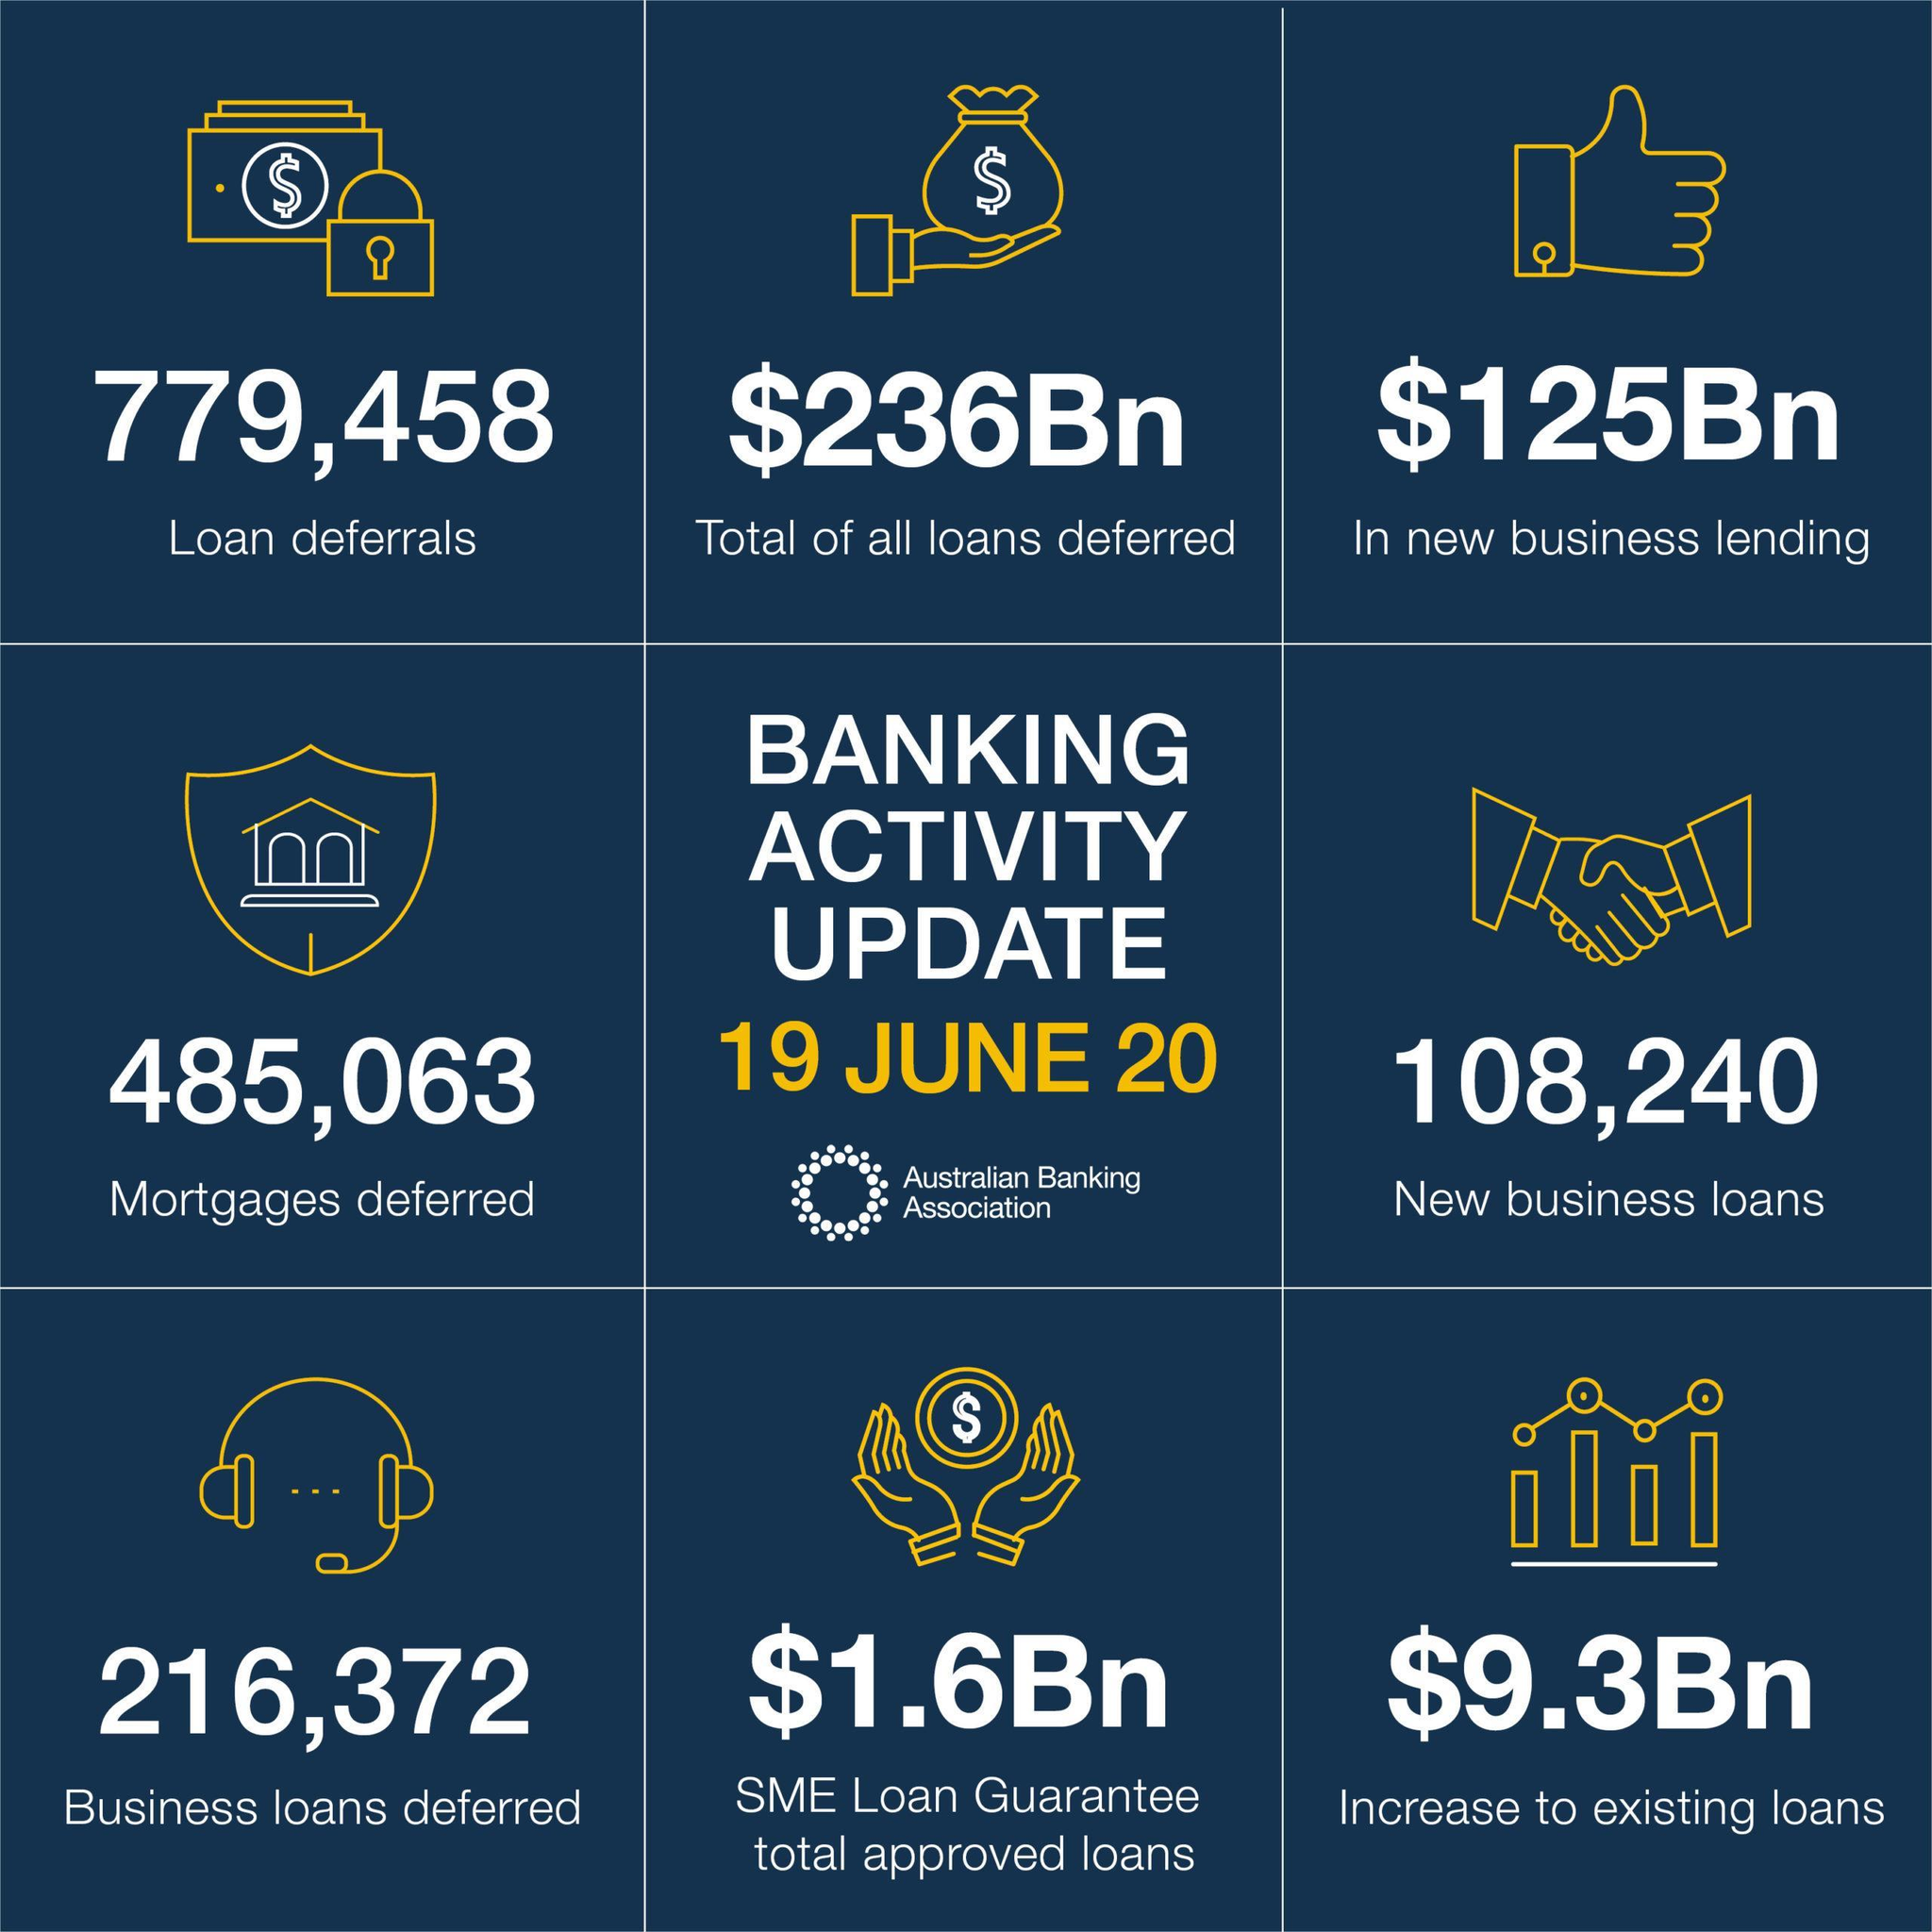How many loan deferrals?
Answer the question with a short phrase. 779,458 How many business loans deferred? 216,372 How many new business loans? 108,240 